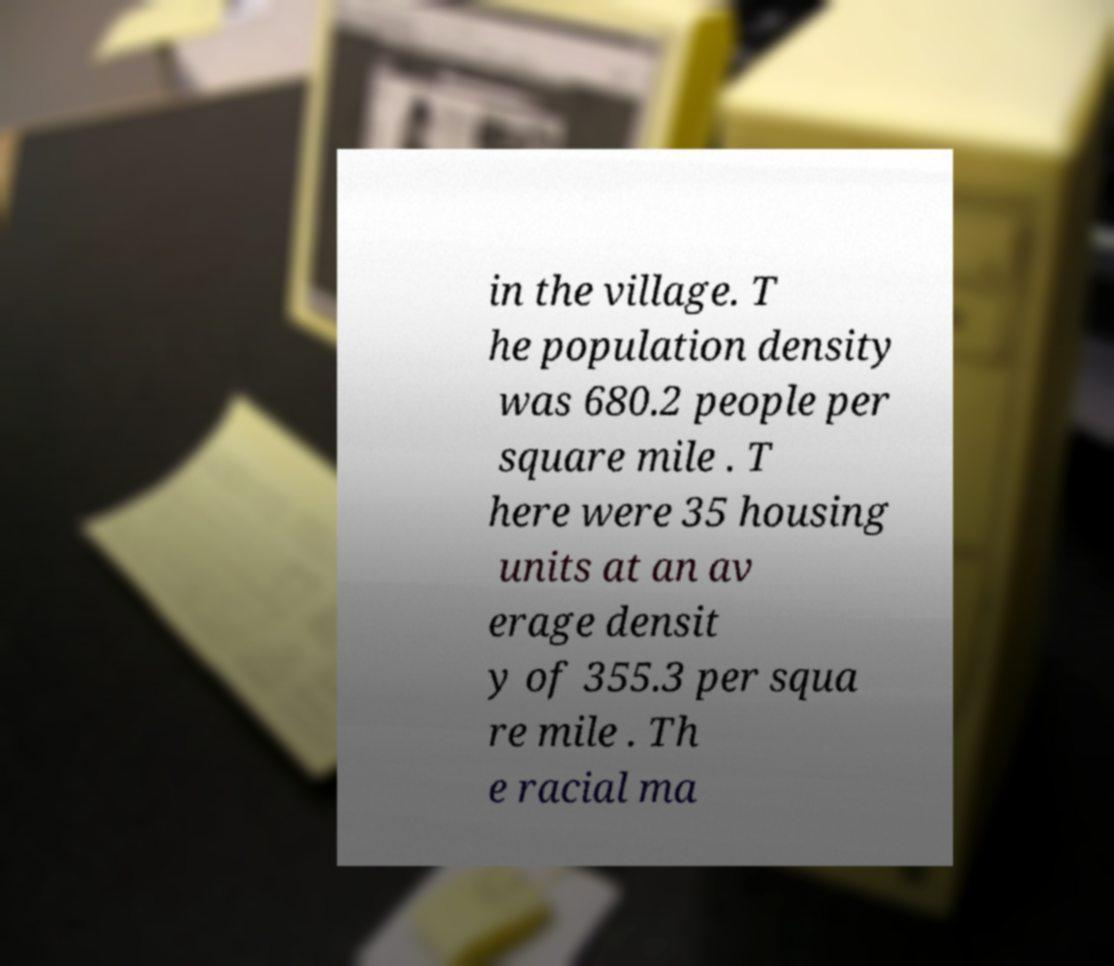Could you extract and type out the text from this image? in the village. T he population density was 680.2 people per square mile . T here were 35 housing units at an av erage densit y of 355.3 per squa re mile . Th e racial ma 